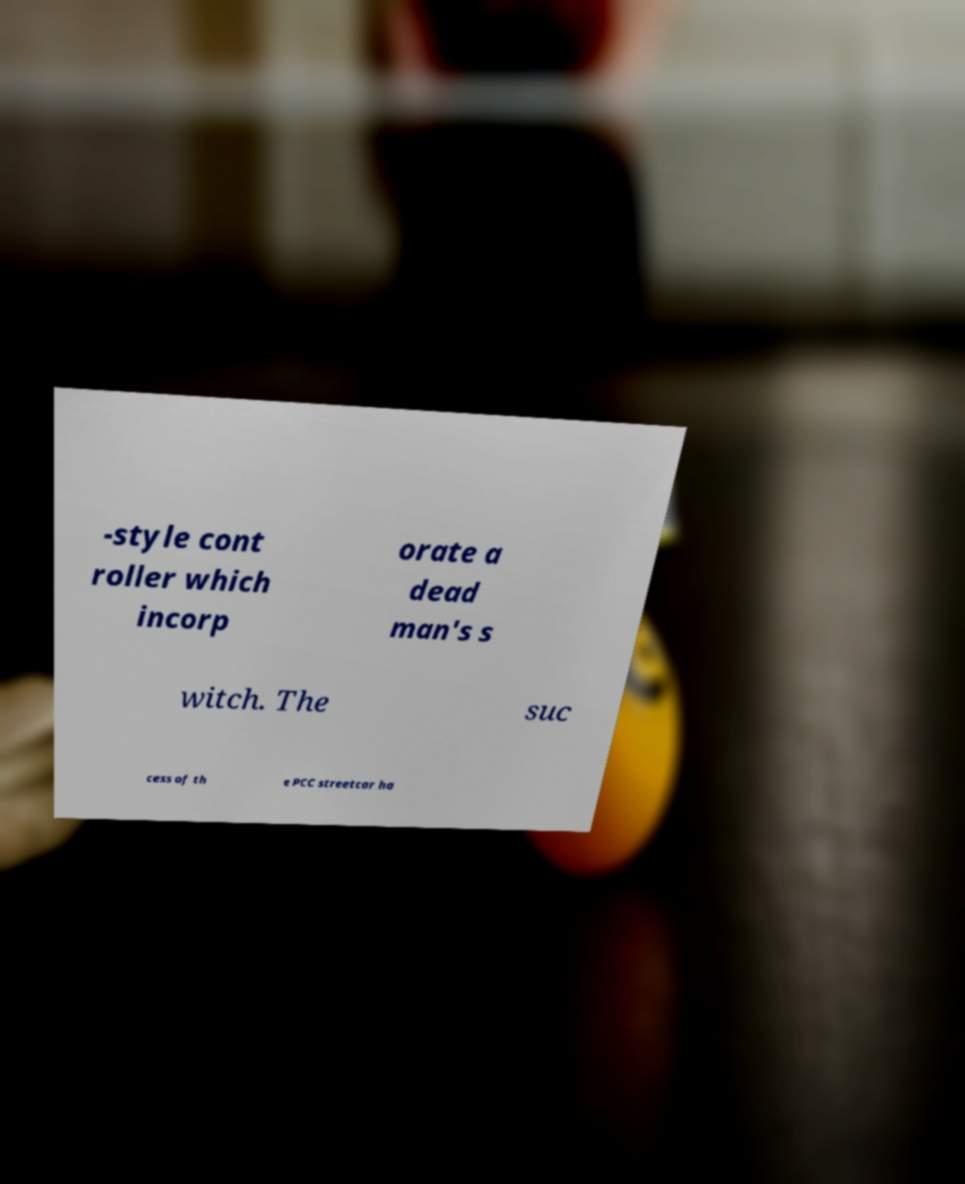There's text embedded in this image that I need extracted. Can you transcribe it verbatim? -style cont roller which incorp orate a dead man's s witch. The suc cess of th e PCC streetcar ha 